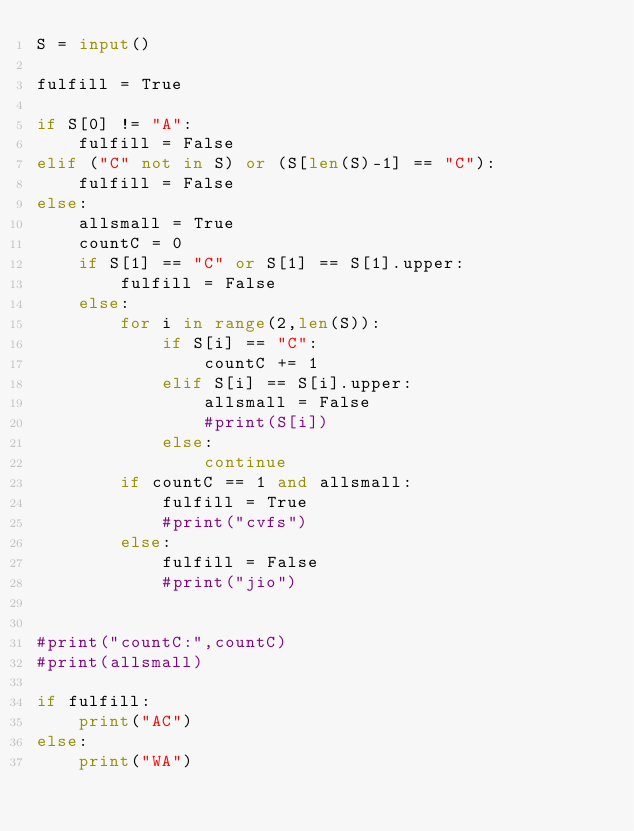Convert code to text. <code><loc_0><loc_0><loc_500><loc_500><_Python_>S = input()

fulfill = True

if S[0] != "A":
    fulfill = False
elif ("C" not in S) or (S[len(S)-1] == "C"):
    fulfill = False
else:
    allsmall = True
    countC = 0
    if S[1] == "C" or S[1] == S[1].upper:
        fulfill = False
    else:
        for i in range(2,len(S)):
            if S[i] == "C":
                countC += 1
            elif S[i] == S[i].upper:
                allsmall = False
                #print(S[i])
            else:
                continue
        if countC == 1 and allsmall:
            fulfill = True
            #print("cvfs")
        else:
            fulfill = False
            #print("jio")


#print("countC:",countC)
#print(allsmall)

if fulfill:
    print("AC")
else:
    print("WA")</code> 